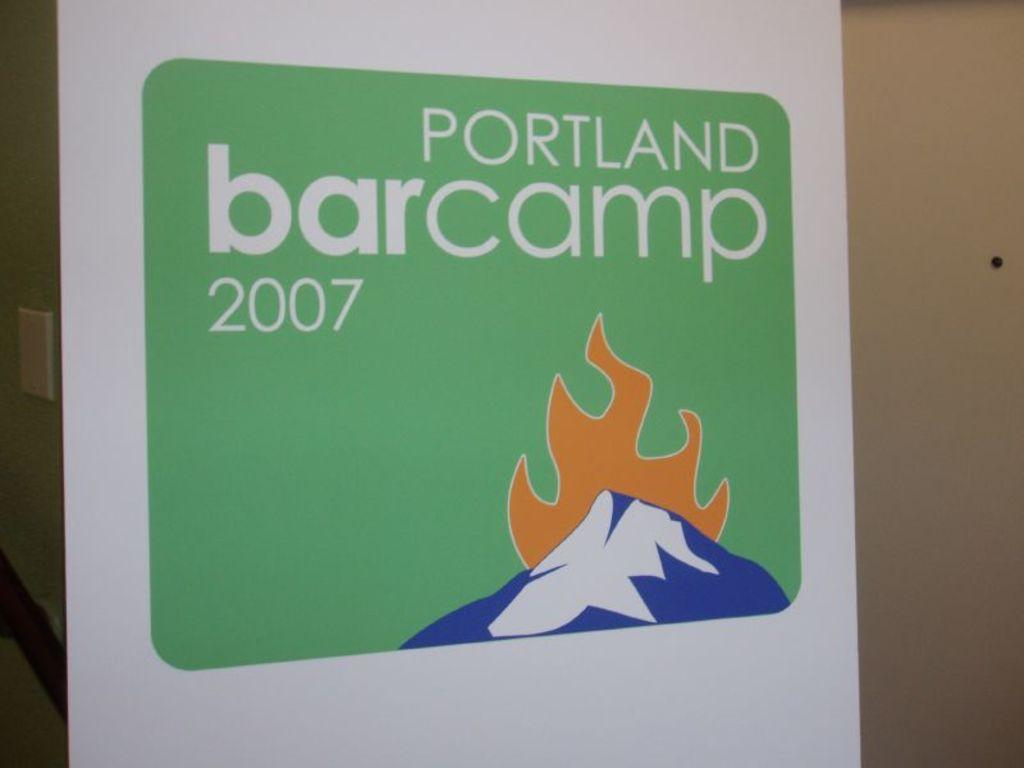Provide a one-sentence caption for the provided image. a sign that says portland camp on it with a mountain scene. 